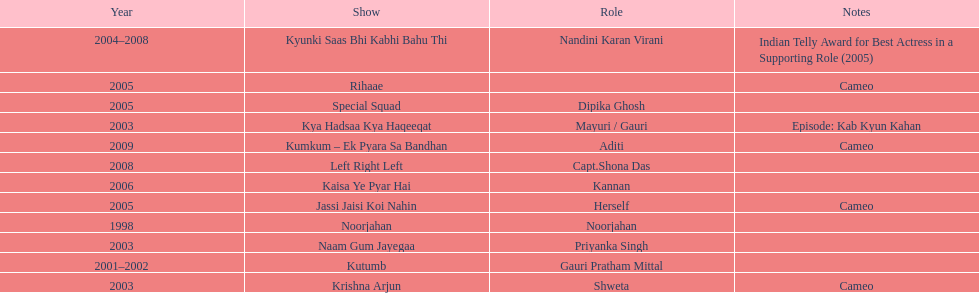Which was the only television show gauri starred in, in which she played herself? Jassi Jaisi Koi Nahin. Could you help me parse every detail presented in this table? {'header': ['Year', 'Show', 'Role', 'Notes'], 'rows': [['2004–2008', 'Kyunki Saas Bhi Kabhi Bahu Thi', 'Nandini Karan Virani', 'Indian Telly Award for Best Actress in a Supporting Role (2005)'], ['2005', 'Rihaae', '', 'Cameo'], ['2005', 'Special Squad', 'Dipika Ghosh', ''], ['2003', 'Kya Hadsaa Kya Haqeeqat', 'Mayuri / Gauri', 'Episode: Kab Kyun Kahan'], ['2009', 'Kumkum – Ek Pyara Sa Bandhan', 'Aditi', 'Cameo'], ['2008', 'Left Right Left', 'Capt.Shona Das', ''], ['2006', 'Kaisa Ye Pyar Hai', 'Kannan', ''], ['2005', 'Jassi Jaisi Koi Nahin', 'Herself', 'Cameo'], ['1998', 'Noorjahan', 'Noorjahan', ''], ['2003', 'Naam Gum Jayegaa', 'Priyanka Singh', ''], ['2001–2002', 'Kutumb', 'Gauri Pratham Mittal', ''], ['2003', 'Krishna Arjun', 'Shweta', 'Cameo']]} 